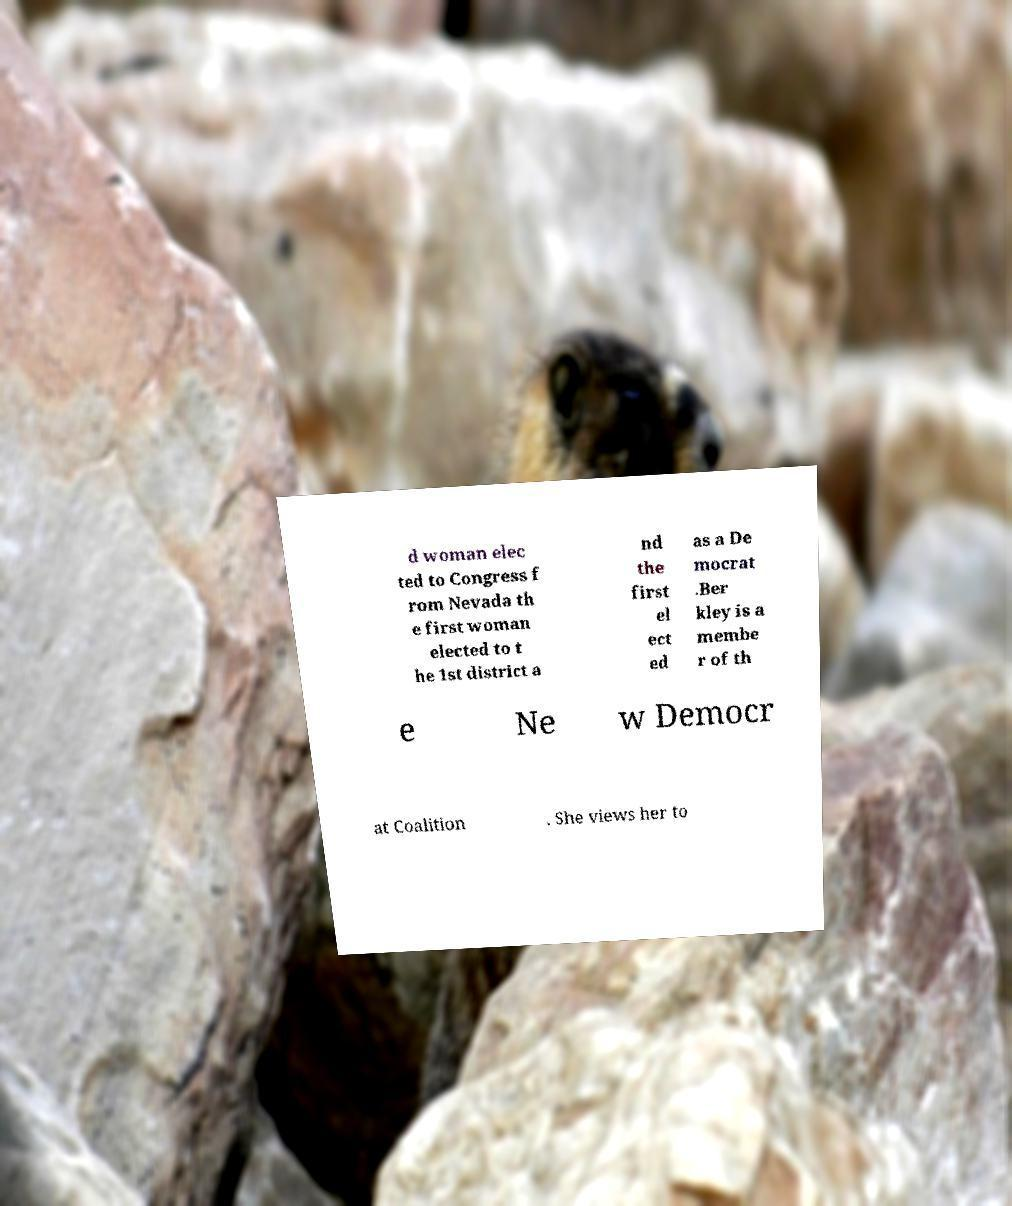Could you assist in decoding the text presented in this image and type it out clearly? d woman elec ted to Congress f rom Nevada th e first woman elected to t he 1st district a nd the first el ect ed as a De mocrat .Ber kley is a membe r of th e Ne w Democr at Coalition . She views her to 